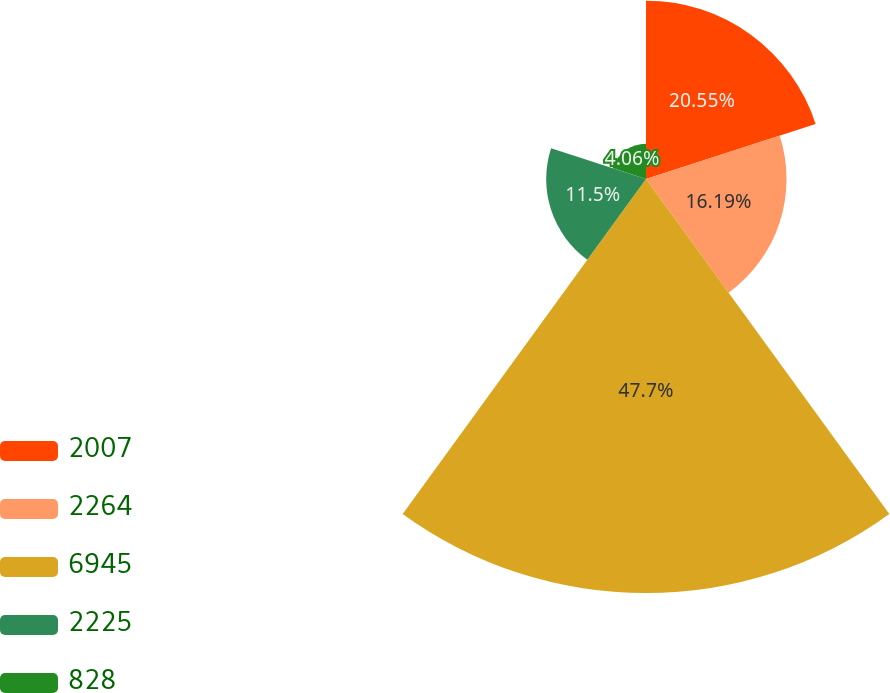Convert chart to OTSL. <chart><loc_0><loc_0><loc_500><loc_500><pie_chart><fcel>2007<fcel>2264<fcel>6945<fcel>2225<fcel>828<nl><fcel>20.55%<fcel>16.19%<fcel>47.7%<fcel>11.5%<fcel>4.06%<nl></chart> 